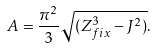Convert formula to latex. <formula><loc_0><loc_0><loc_500><loc_500>A = { \frac { \pi ^ { 2 } } { 3 } } \sqrt { ( Z _ { f i x } ^ { 3 } - J ^ { 2 } ) } .</formula> 